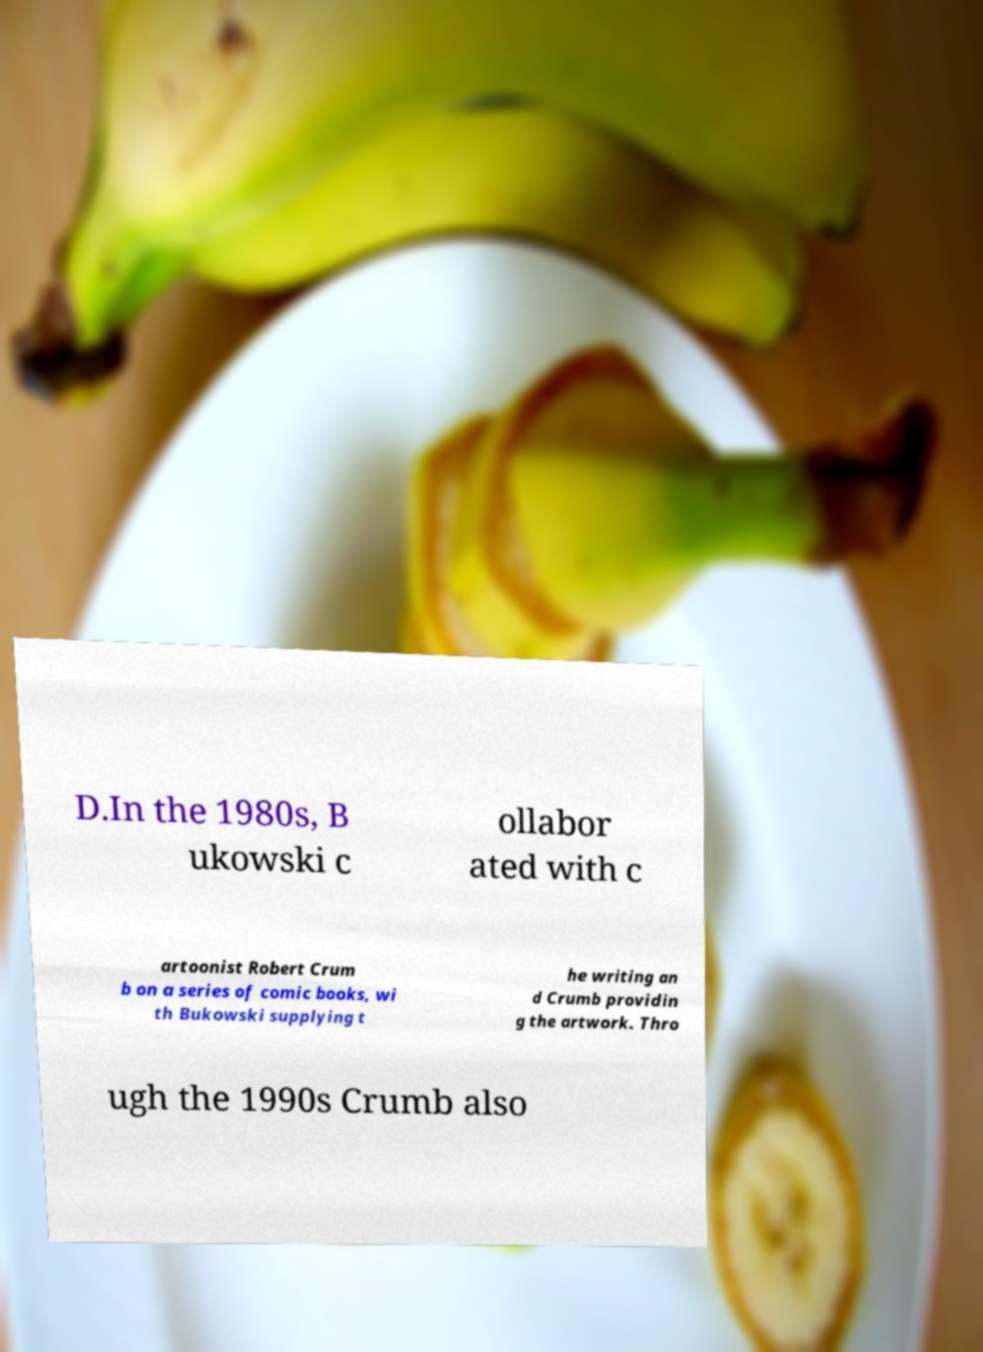Could you extract and type out the text from this image? D.In the 1980s, B ukowski c ollabor ated with c artoonist Robert Crum b on a series of comic books, wi th Bukowski supplying t he writing an d Crumb providin g the artwork. Thro ugh the 1990s Crumb also 